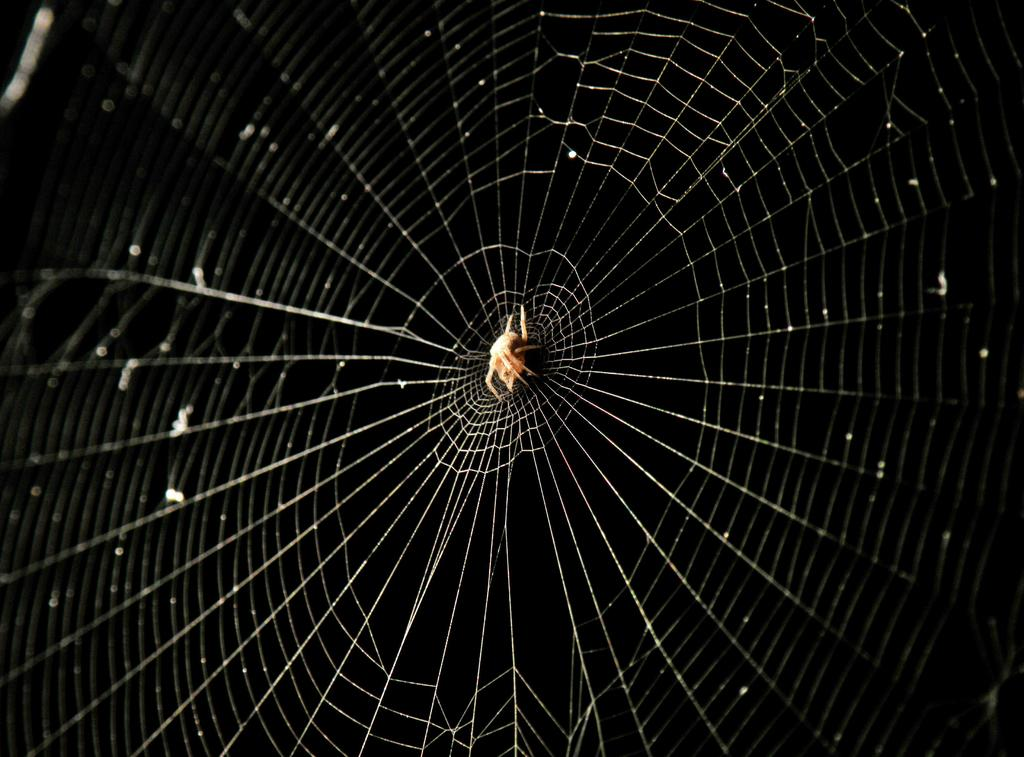What is the main subject of the image? There is a spider in the image. Where is the spider located? The spider is on a web. What is the color of the background in the image? The background of the image is black. Can you see a train passing by in the background of the image? There is no train present in the image. 